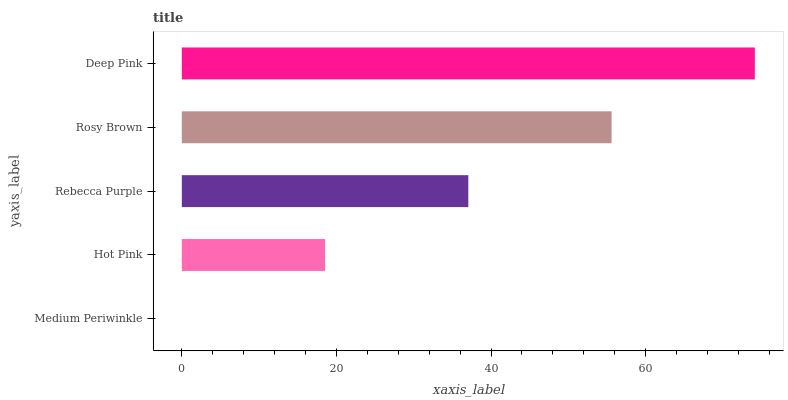Is Medium Periwinkle the minimum?
Answer yes or no. Yes. Is Deep Pink the maximum?
Answer yes or no. Yes. Is Hot Pink the minimum?
Answer yes or no. No. Is Hot Pink the maximum?
Answer yes or no. No. Is Hot Pink greater than Medium Periwinkle?
Answer yes or no. Yes. Is Medium Periwinkle less than Hot Pink?
Answer yes or no. Yes. Is Medium Periwinkle greater than Hot Pink?
Answer yes or no. No. Is Hot Pink less than Medium Periwinkle?
Answer yes or no. No. Is Rebecca Purple the high median?
Answer yes or no. Yes. Is Rebecca Purple the low median?
Answer yes or no. Yes. Is Rosy Brown the high median?
Answer yes or no. No. Is Medium Periwinkle the low median?
Answer yes or no. No. 